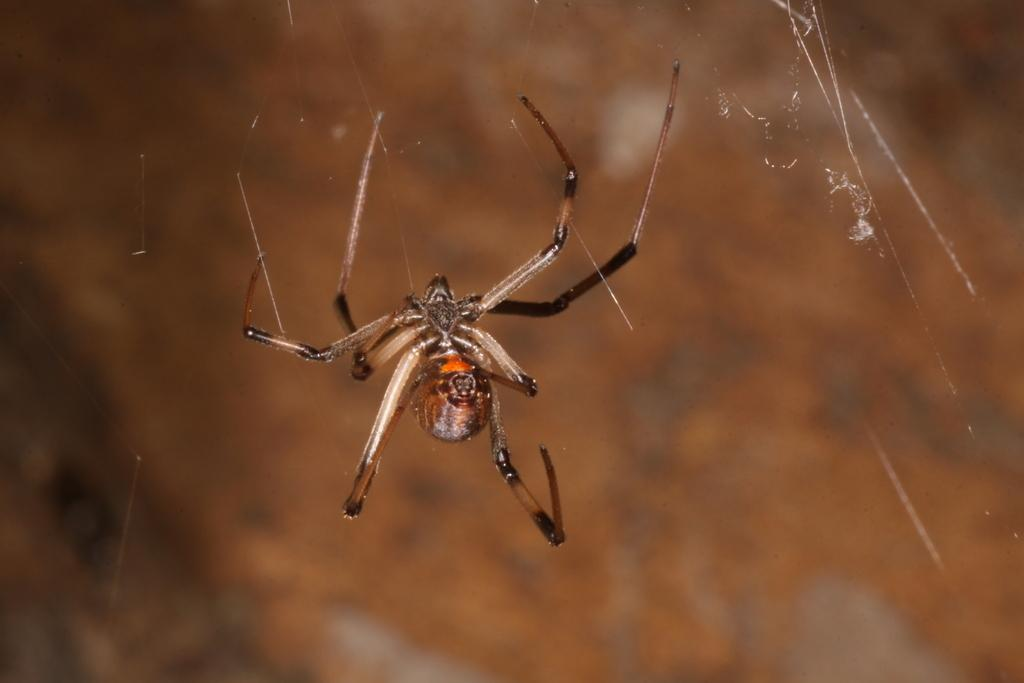What is the main subject of the image? The main subject of the image is a spider. Can you describe the background of the image? The background of the image is blurry. What type of behavior can be observed in the cemetery in the image? There is no cemetery present in the image, and therefore no such behavior can be observed. 